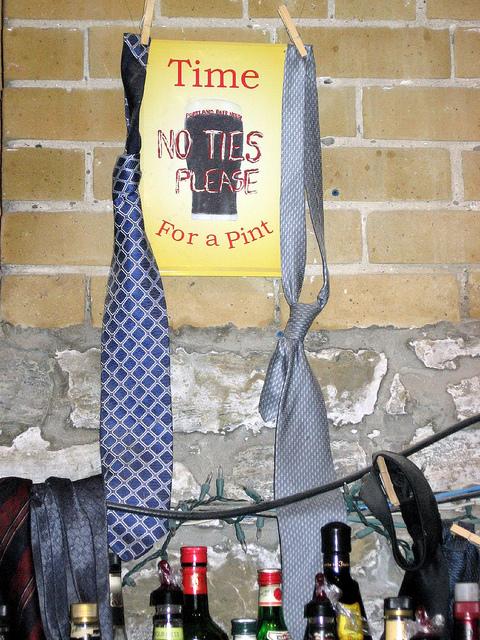Is there liquor bottles?
Be succinct. Yes. Are the having a "no ties" party?
Write a very short answer. Yes. What material is the wall?
Quick response, please. Brick. 